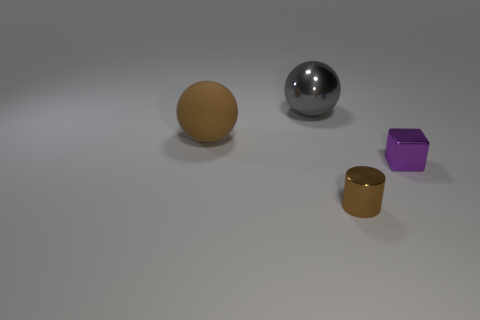What number of tiny cylinders are the same color as the large matte ball?
Keep it short and to the point. 1. There is a object that is the same size as the block; what is its shape?
Provide a short and direct response. Cylinder. Is there a tiny gray thing of the same shape as the brown rubber object?
Ensure brevity in your answer.  No. What number of large purple things have the same material as the gray object?
Provide a short and direct response. 0. Is the sphere on the left side of the gray shiny sphere made of the same material as the cube?
Your response must be concise. No. Are there more brown metallic objects on the left side of the large brown rubber object than brown metal cylinders that are behind the purple metallic object?
Offer a terse response. No. There is a cube that is the same size as the brown shiny cylinder; what is it made of?
Provide a succinct answer. Metal. What number of other things are the same material as the gray sphere?
Your answer should be very brief. 2. There is a brown thing on the right side of the shiny ball; is it the same shape as the object that is behind the brown matte ball?
Ensure brevity in your answer.  No. How many other objects are the same color as the small shiny cylinder?
Give a very brief answer. 1. 